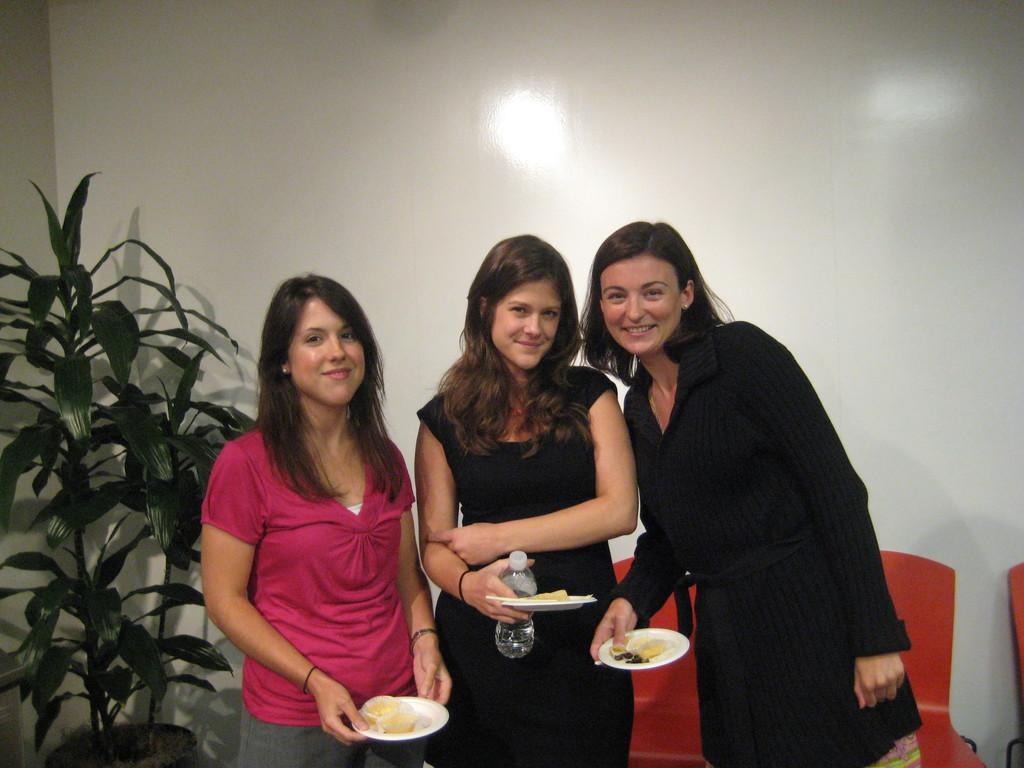How many women are in the foreground of the image? There are three women in the foreground of the image. What are the women holding in the image? The women are holding platters, and one woman is holding a bottle. What can be seen in the background of the image? There is a plant, a wall, and chairs in the background of the image. What type of clouds can be seen in the image? There are no clouds visible in the image. Is there a harbor depicted in the image? No, there is no harbor present in the image. 